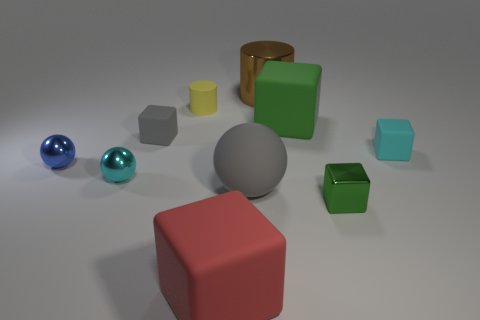Does the gray thing to the right of the red rubber cube have the same size as the tiny yellow matte cylinder?
Offer a very short reply. No. Does the big shiny object have the same color as the rubber cylinder?
Provide a short and direct response. No. How many large brown metallic cylinders are there?
Give a very brief answer. 1. How many blocks are either small cyan objects or small blue things?
Offer a very short reply. 1. What number of small cyan metallic things are in front of the tiny matte block to the right of the green shiny object?
Make the answer very short. 1. Are the big brown object and the gray ball made of the same material?
Provide a short and direct response. No. There is a object that is the same color as the large rubber sphere; what is its size?
Your answer should be compact. Small. Is there a small red thing that has the same material as the tiny yellow cylinder?
Make the answer very short. No. What is the color of the cube in front of the green thing on the right side of the large object to the right of the big metallic object?
Make the answer very short. Red. What number of brown objects are either small metallic blocks or large things?
Provide a succinct answer. 1. 